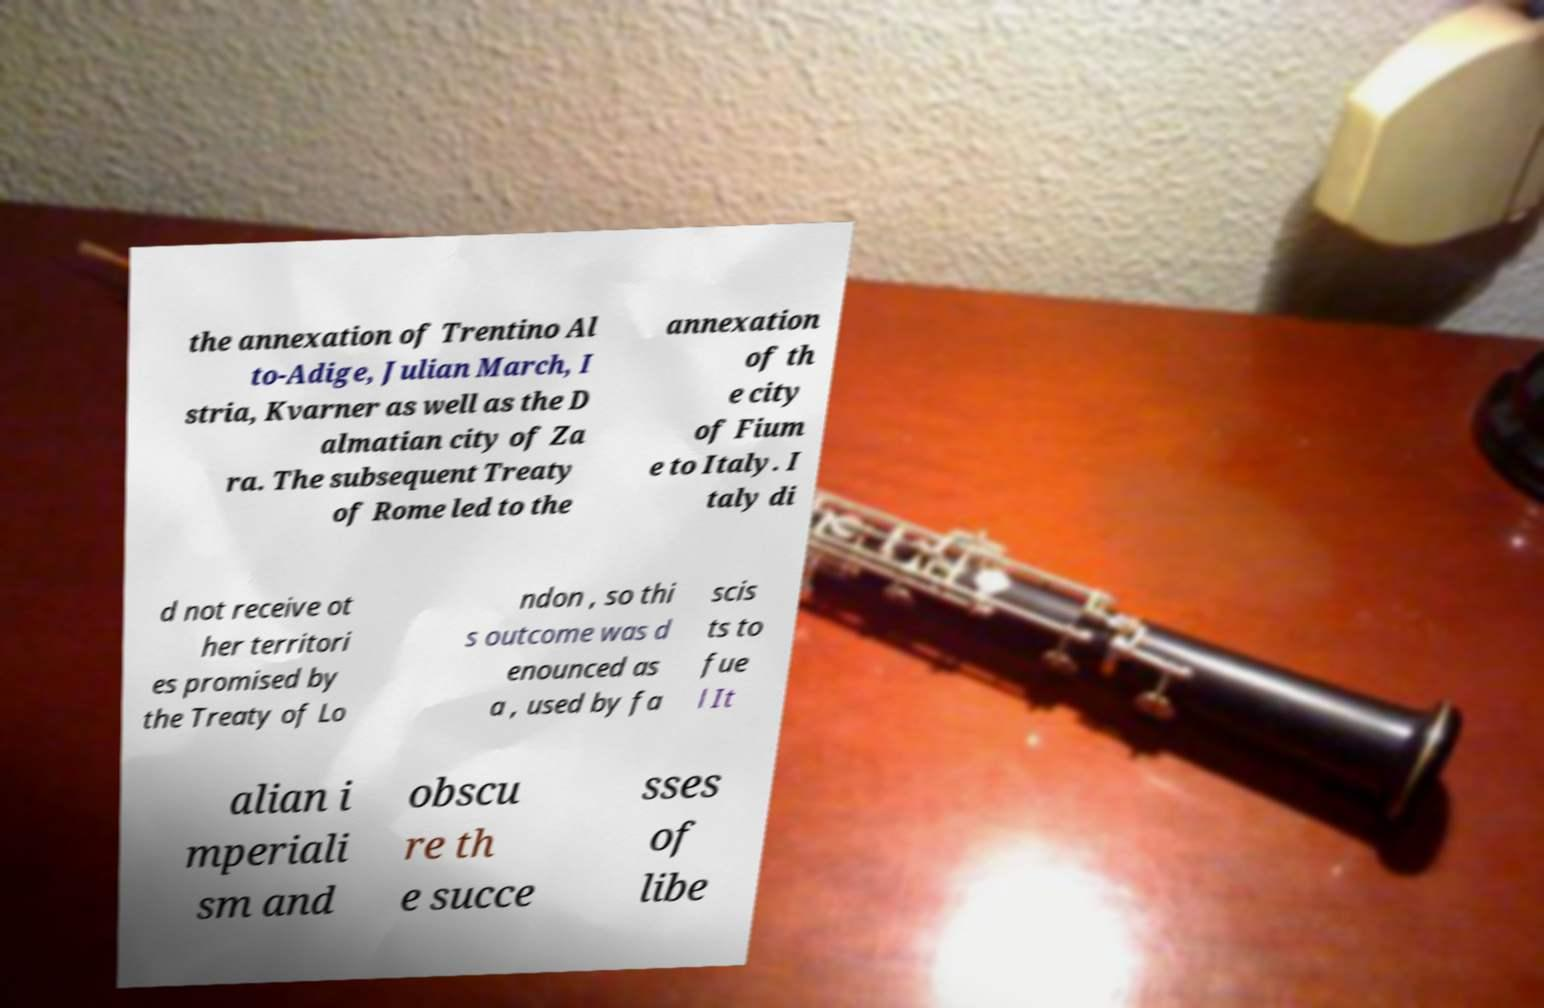I need the written content from this picture converted into text. Can you do that? the annexation of Trentino Al to-Adige, Julian March, I stria, Kvarner as well as the D almatian city of Za ra. The subsequent Treaty of Rome led to the annexation of th e city of Fium e to Italy. I taly di d not receive ot her territori es promised by the Treaty of Lo ndon , so thi s outcome was d enounced as a , used by fa scis ts to fue l It alian i mperiali sm and obscu re th e succe sses of libe 